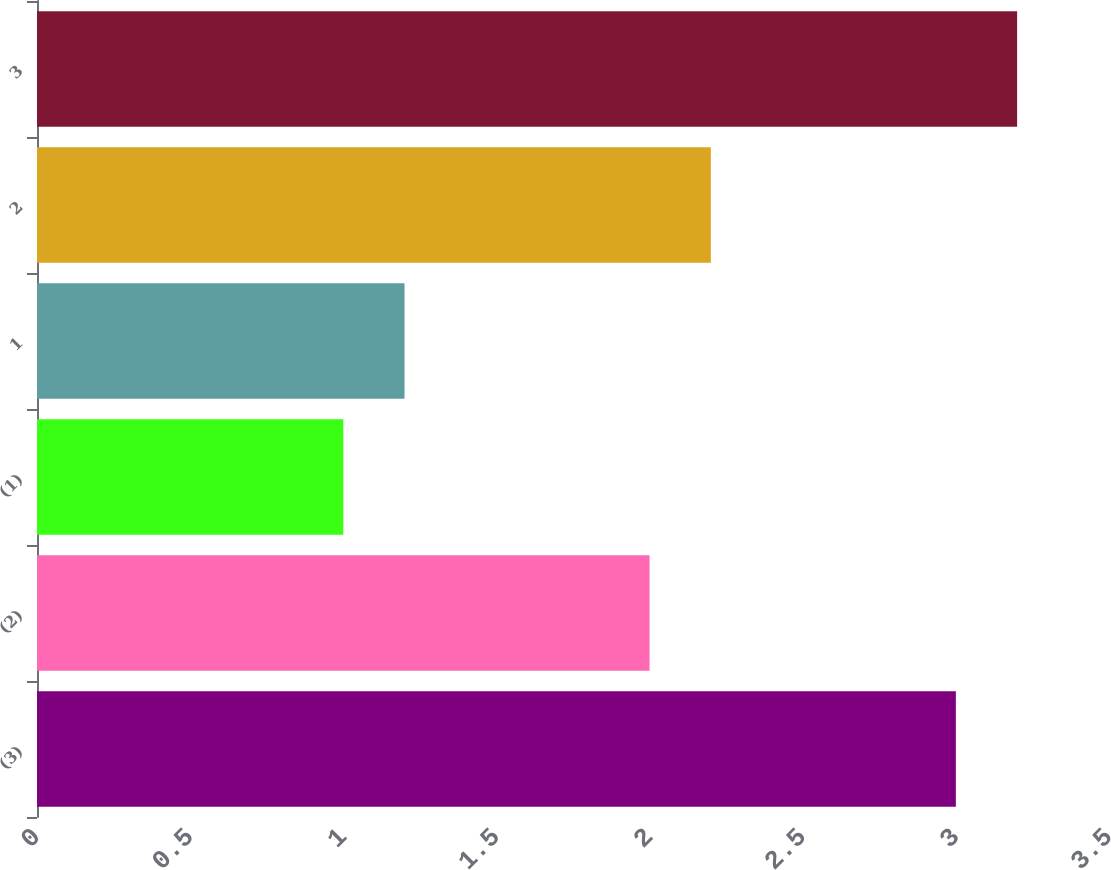Convert chart. <chart><loc_0><loc_0><loc_500><loc_500><bar_chart><fcel>(3)<fcel>(2)<fcel>(1)<fcel>1<fcel>2<fcel>3<nl><fcel>3<fcel>2<fcel>1<fcel>1.2<fcel>2.2<fcel>3.2<nl></chart> 